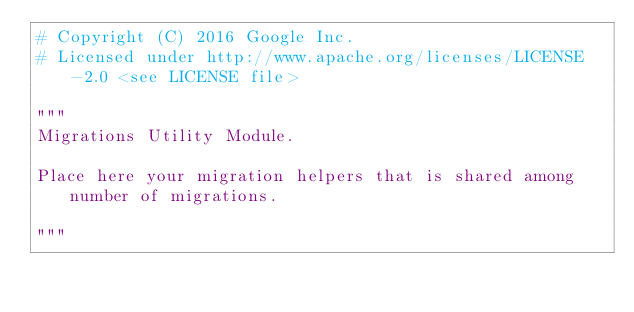Convert code to text. <code><loc_0><loc_0><loc_500><loc_500><_Python_># Copyright (C) 2016 Google Inc.
# Licensed under http://www.apache.org/licenses/LICENSE-2.0 <see LICENSE file>

"""
Migrations Utility Module.

Place here your migration helpers that is shared among number of migrations.

"""
</code> 